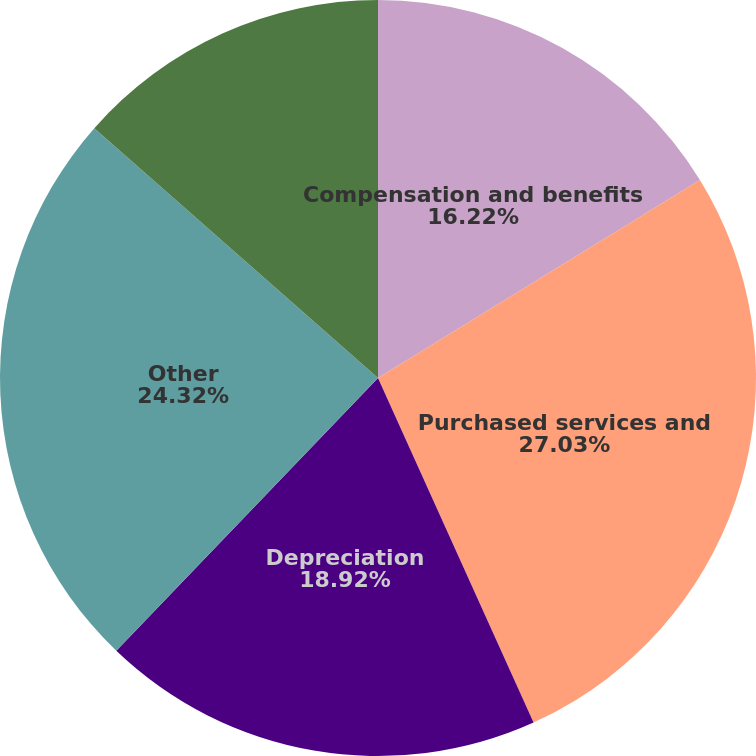<chart> <loc_0><loc_0><loc_500><loc_500><pie_chart><fcel>Compensation and benefits<fcel>Purchased services and<fcel>Depreciation<fcel>Other<fcel>Total<nl><fcel>16.22%<fcel>27.03%<fcel>18.92%<fcel>24.32%<fcel>13.51%<nl></chart> 